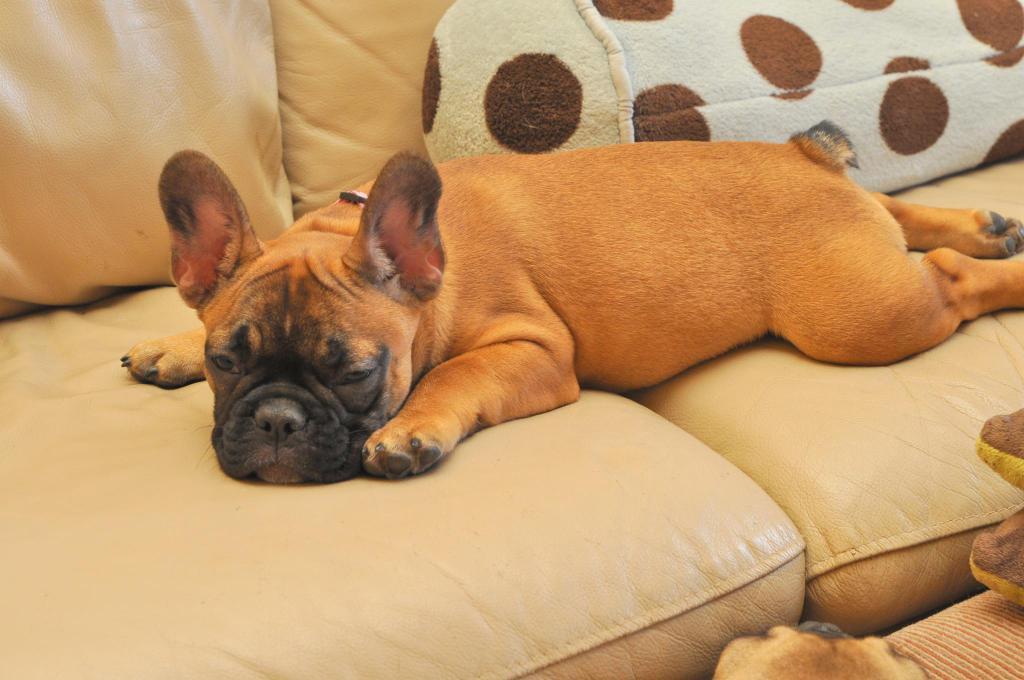Describe this image in one or two sentences. There is a dog on sofa and we can see pillow. 